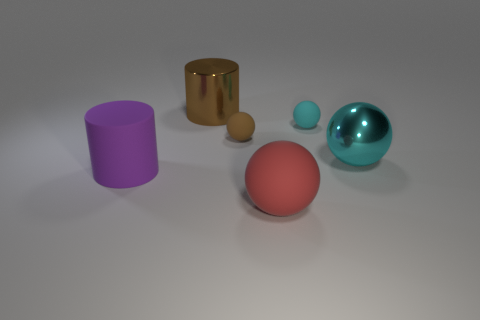Subtract all metal balls. How many balls are left? 3 Subtract all balls. How many objects are left? 2 Subtract 3 balls. How many balls are left? 1 Add 3 large brown cylinders. How many large brown cylinders are left? 4 Add 4 tiny brown matte things. How many tiny brown matte things exist? 5 Add 2 red rubber spheres. How many objects exist? 8 Subtract all brown balls. How many balls are left? 3 Subtract 0 cyan cylinders. How many objects are left? 6 Subtract all purple balls. Subtract all blue cylinders. How many balls are left? 4 Subtract all cyan balls. How many red cylinders are left? 0 